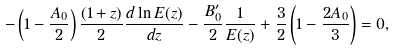Convert formula to latex. <formula><loc_0><loc_0><loc_500><loc_500>- \left ( 1 - \frac { A _ { 0 } } { 2 } \right ) \frac { ( 1 + z ) } { 2 } \frac { d \ln E ( z ) } { d z } - \frac { B ^ { \prime } _ { 0 } } { 2 } \frac { 1 } { E ( z ) } + \frac { 3 } { 2 } \left ( 1 - \frac { 2 A _ { 0 } } { 3 } \right ) = 0 ,</formula> 